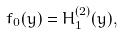Convert formula to latex. <formula><loc_0><loc_0><loc_500><loc_500>f _ { 0 } ( y ) = H _ { 1 } ^ { ( 2 ) } ( y ) ,</formula> 